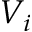<formula> <loc_0><loc_0><loc_500><loc_500>V _ { i }</formula> 